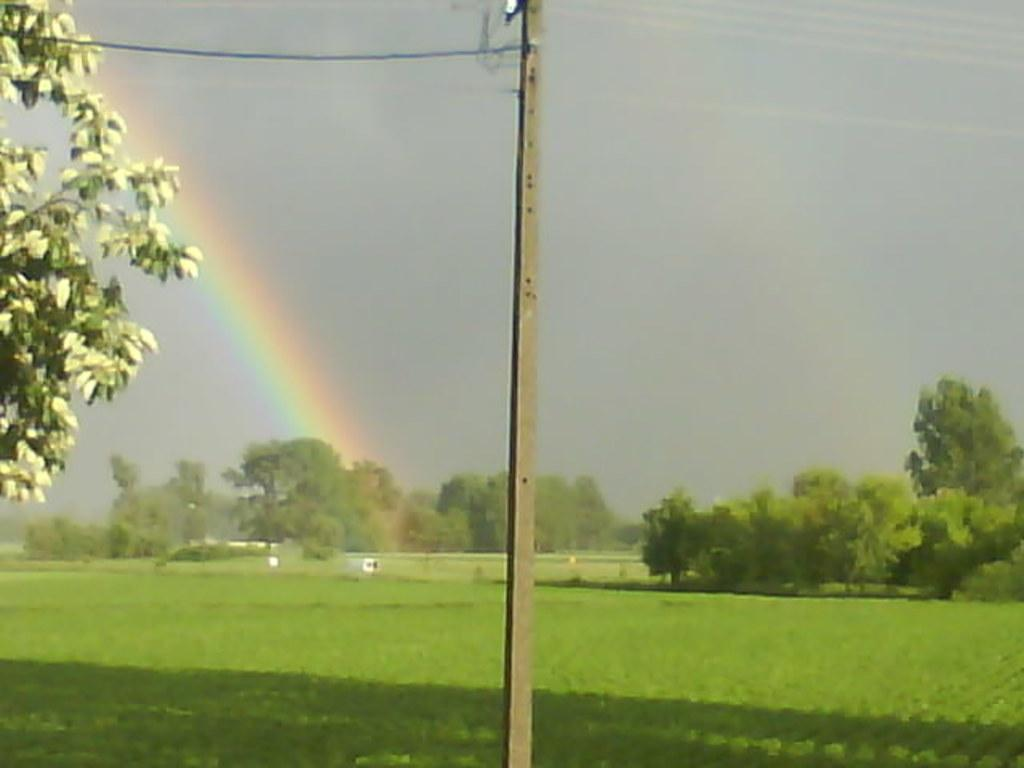What is present on the electric pole in the image? There are cables on the electric pole in the image. What natural phenomenon can be seen behind the pole? There is a rainbow behind the pole in the image. What type of landscape is visible in the image? There are fields visible in the image. What other natural elements can be seen in the image? There are trees in the image. What part of the environment is visible in the image? The sky is visible in the image. What type of oil can be seen dripping from the electric pole in the image? There is no oil present or dripping from the electric pole in the image. How many yaks are visible in the image? There are no yaks present in the image. 